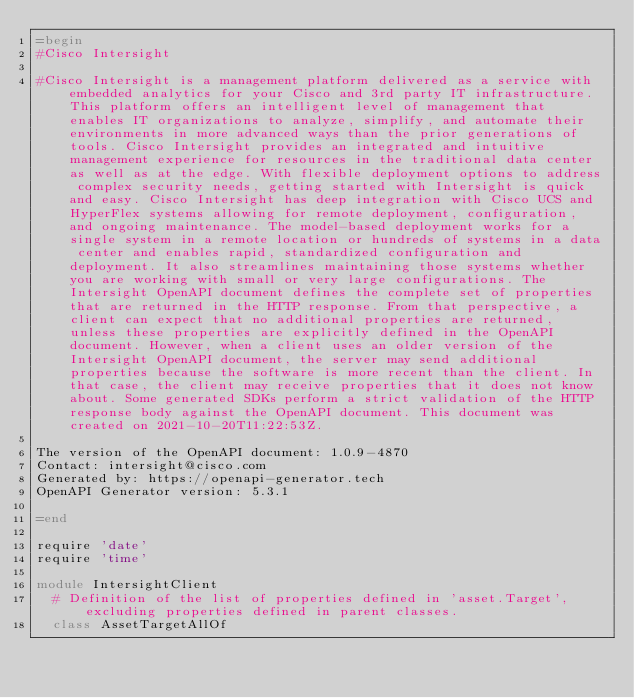<code> <loc_0><loc_0><loc_500><loc_500><_Ruby_>=begin
#Cisco Intersight

#Cisco Intersight is a management platform delivered as a service with embedded analytics for your Cisco and 3rd party IT infrastructure. This platform offers an intelligent level of management that enables IT organizations to analyze, simplify, and automate their environments in more advanced ways than the prior generations of tools. Cisco Intersight provides an integrated and intuitive management experience for resources in the traditional data center as well as at the edge. With flexible deployment options to address complex security needs, getting started with Intersight is quick and easy. Cisco Intersight has deep integration with Cisco UCS and HyperFlex systems allowing for remote deployment, configuration, and ongoing maintenance. The model-based deployment works for a single system in a remote location or hundreds of systems in a data center and enables rapid, standardized configuration and deployment. It also streamlines maintaining those systems whether you are working with small or very large configurations. The Intersight OpenAPI document defines the complete set of properties that are returned in the HTTP response. From that perspective, a client can expect that no additional properties are returned, unless these properties are explicitly defined in the OpenAPI document. However, when a client uses an older version of the Intersight OpenAPI document, the server may send additional properties because the software is more recent than the client. In that case, the client may receive properties that it does not know about. Some generated SDKs perform a strict validation of the HTTP response body against the OpenAPI document. This document was created on 2021-10-20T11:22:53Z.

The version of the OpenAPI document: 1.0.9-4870
Contact: intersight@cisco.com
Generated by: https://openapi-generator.tech
OpenAPI Generator version: 5.3.1

=end

require 'date'
require 'time'

module IntersightClient
  # Definition of the list of properties defined in 'asset.Target', excluding properties defined in parent classes.
  class AssetTargetAllOf</code> 